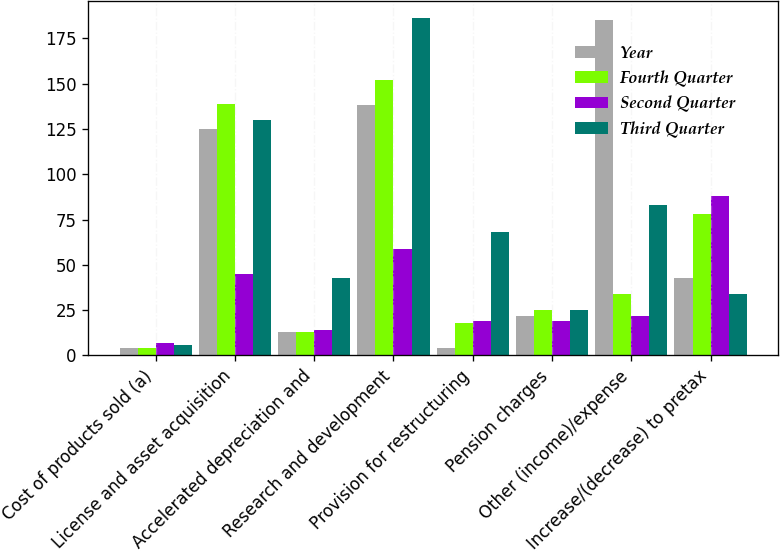Convert chart to OTSL. <chart><loc_0><loc_0><loc_500><loc_500><stacked_bar_chart><ecel><fcel>Cost of products sold (a)<fcel>License and asset acquisition<fcel>Accelerated depreciation and<fcel>Research and development<fcel>Provision for restructuring<fcel>Pension charges<fcel>Other (income)/expense<fcel>Increase/(decrease) to pretax<nl><fcel>Year<fcel>4<fcel>125<fcel>13<fcel>138<fcel>4<fcel>22<fcel>185<fcel>43<nl><fcel>Fourth Quarter<fcel>4<fcel>139<fcel>13<fcel>152<fcel>18<fcel>25<fcel>34<fcel>78<nl><fcel>Second Quarter<fcel>7<fcel>45<fcel>14<fcel>59<fcel>19<fcel>19<fcel>22<fcel>88<nl><fcel>Third Quarter<fcel>6<fcel>130<fcel>43<fcel>186<fcel>68<fcel>25<fcel>83<fcel>34<nl></chart> 